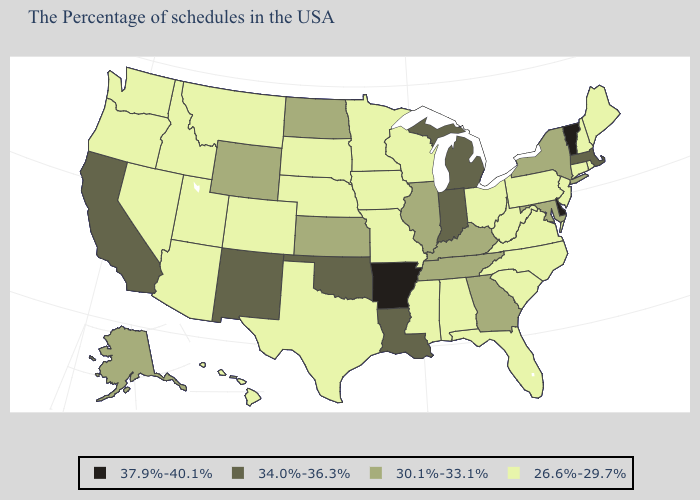Does Nebraska have a lower value than Maryland?
Short answer required. Yes. What is the value of Nevada?
Write a very short answer. 26.6%-29.7%. Which states have the lowest value in the USA?
Answer briefly. Maine, Rhode Island, New Hampshire, Connecticut, New Jersey, Pennsylvania, Virginia, North Carolina, South Carolina, West Virginia, Ohio, Florida, Alabama, Wisconsin, Mississippi, Missouri, Minnesota, Iowa, Nebraska, Texas, South Dakota, Colorado, Utah, Montana, Arizona, Idaho, Nevada, Washington, Oregon, Hawaii. What is the value of Kansas?
Short answer required. 30.1%-33.1%. Among the states that border Arizona , does New Mexico have the lowest value?
Keep it brief. No. Does Maryland have a higher value than New York?
Write a very short answer. No. Does the map have missing data?
Give a very brief answer. No. Name the states that have a value in the range 26.6%-29.7%?
Answer briefly. Maine, Rhode Island, New Hampshire, Connecticut, New Jersey, Pennsylvania, Virginia, North Carolina, South Carolina, West Virginia, Ohio, Florida, Alabama, Wisconsin, Mississippi, Missouri, Minnesota, Iowa, Nebraska, Texas, South Dakota, Colorado, Utah, Montana, Arizona, Idaho, Nevada, Washington, Oregon, Hawaii. What is the value of Texas?
Keep it brief. 26.6%-29.7%. Name the states that have a value in the range 37.9%-40.1%?
Write a very short answer. Vermont, Delaware, Arkansas. Name the states that have a value in the range 37.9%-40.1%?
Be succinct. Vermont, Delaware, Arkansas. Name the states that have a value in the range 30.1%-33.1%?
Quick response, please. New York, Maryland, Georgia, Kentucky, Tennessee, Illinois, Kansas, North Dakota, Wyoming, Alaska. Name the states that have a value in the range 37.9%-40.1%?
Concise answer only. Vermont, Delaware, Arkansas. What is the value of Arkansas?
Give a very brief answer. 37.9%-40.1%. Does Indiana have the lowest value in the USA?
Write a very short answer. No. 